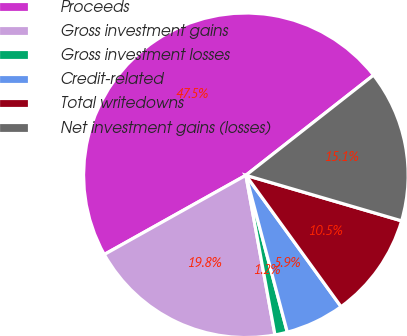Convert chart to OTSL. <chart><loc_0><loc_0><loc_500><loc_500><pie_chart><fcel>Proceeds<fcel>Gross investment gains<fcel>Gross investment losses<fcel>Credit-related<fcel>Total writedowns<fcel>Net investment gains (losses)<nl><fcel>47.53%<fcel>19.75%<fcel>1.24%<fcel>5.87%<fcel>10.49%<fcel>15.12%<nl></chart> 